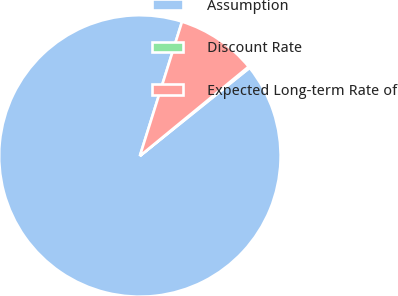Convert chart. <chart><loc_0><loc_0><loc_500><loc_500><pie_chart><fcel>Assumption<fcel>Discount Rate<fcel>Expected Long-term Rate of<nl><fcel>90.61%<fcel>0.17%<fcel>9.22%<nl></chart> 